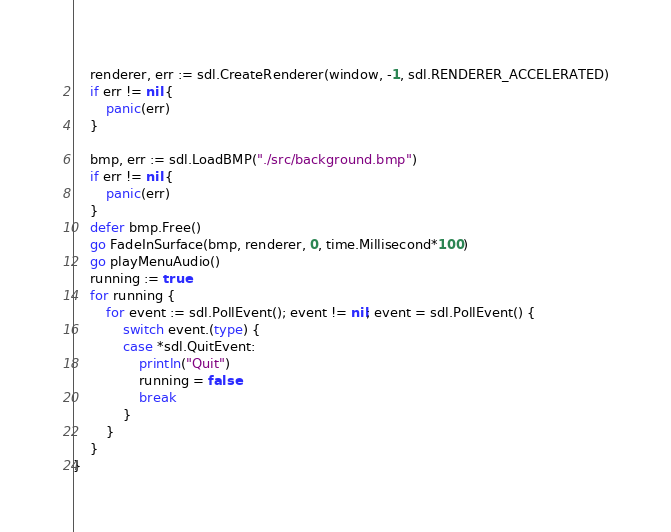<code> <loc_0><loc_0><loc_500><loc_500><_Go_>	renderer, err := sdl.CreateRenderer(window, -1, sdl.RENDERER_ACCELERATED)
	if err != nil {
		panic(err)
	}

	bmp, err := sdl.LoadBMP("./src/background.bmp")
	if err != nil {
		panic(err)
	}
	defer bmp.Free()
	go FadeInSurface(bmp, renderer, 0, time.Millisecond*100)
	go playMenuAudio()
	running := true
	for running {
		for event := sdl.PollEvent(); event != nil; event = sdl.PollEvent() {
			switch event.(type) {
			case *sdl.QuitEvent:
				println("Quit")
				running = false
				break
			}
		}
	}
}
</code> 